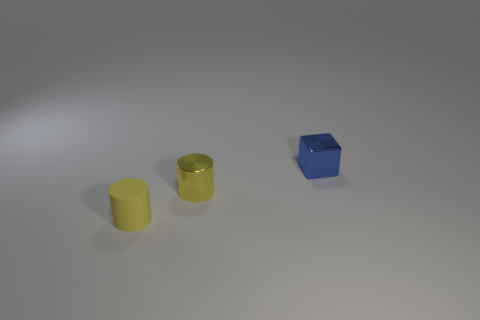What number of other objects are there of the same color as the small cube?
Keep it short and to the point. 0. What material is the block?
Offer a terse response. Metal. What number of other things are made of the same material as the blue cube?
Your answer should be compact. 1. What shape is the tiny yellow thing in front of the tiny yellow thing that is behind the matte object?
Keep it short and to the point. Cylinder. Is there any other thing that has the same shape as the small blue metal object?
Ensure brevity in your answer.  No. Is the number of small yellow cylinders in front of the small metallic cylinder the same as the number of matte cylinders?
Offer a very short reply. Yes. There is a small rubber thing; does it have the same color as the shiny object to the left of the tiny blue shiny block?
Give a very brief answer. Yes. There is a thing that is to the right of the yellow matte cylinder and in front of the cube; what color is it?
Give a very brief answer. Yellow. There is a tiny metal object in front of the blue metal cube; how many objects are behind it?
Ensure brevity in your answer.  1. Are there any tiny yellow metal objects that have the same shape as the tiny yellow matte object?
Make the answer very short. Yes. 